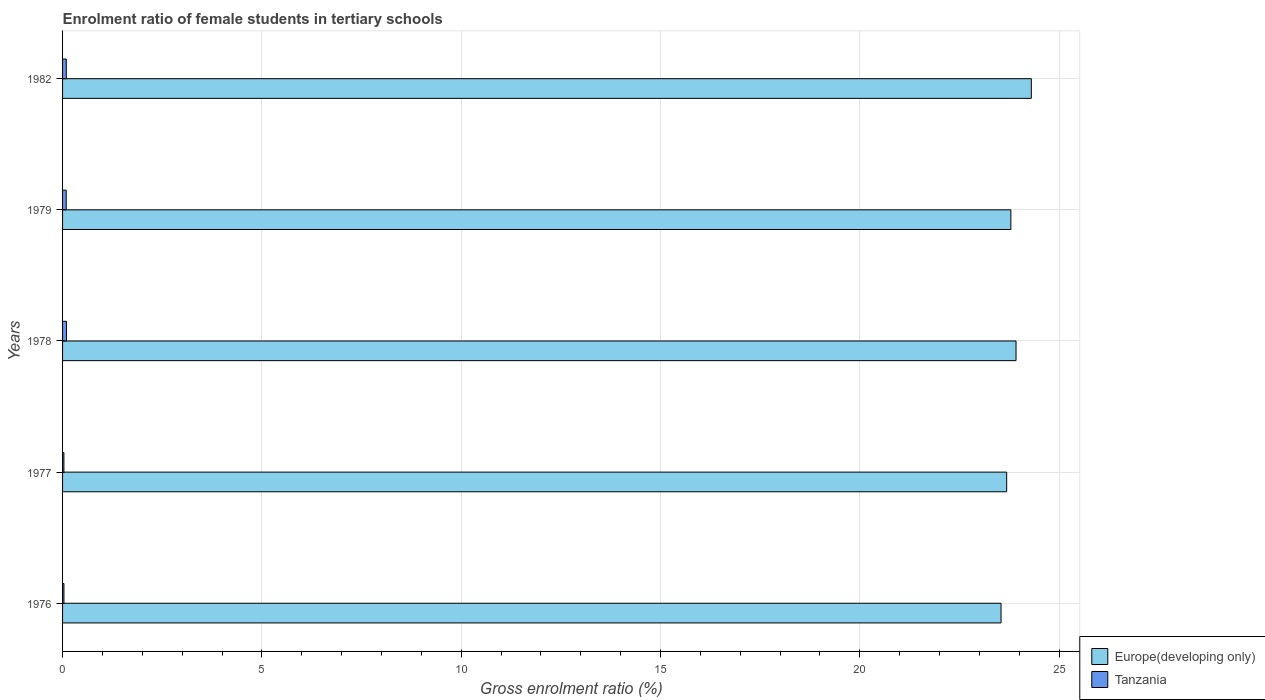How many groups of bars are there?
Give a very brief answer. 5. Are the number of bars on each tick of the Y-axis equal?
Your answer should be very brief. Yes. How many bars are there on the 2nd tick from the top?
Offer a terse response. 2. What is the label of the 2nd group of bars from the top?
Offer a terse response. 1979. What is the enrolment ratio of female students in tertiary schools in Europe(developing only) in 1976?
Your answer should be compact. 23.54. Across all years, what is the maximum enrolment ratio of female students in tertiary schools in Europe(developing only)?
Offer a very short reply. 24.3. Across all years, what is the minimum enrolment ratio of female students in tertiary schools in Europe(developing only)?
Make the answer very short. 23.54. In which year was the enrolment ratio of female students in tertiary schools in Tanzania maximum?
Your answer should be compact. 1978. What is the total enrolment ratio of female students in tertiary schools in Tanzania in the graph?
Your response must be concise. 0.35. What is the difference between the enrolment ratio of female students in tertiary schools in Europe(developing only) in 1979 and that in 1982?
Offer a very short reply. -0.51. What is the difference between the enrolment ratio of female students in tertiary schools in Tanzania in 1977 and the enrolment ratio of female students in tertiary schools in Europe(developing only) in 1976?
Offer a very short reply. -23.51. What is the average enrolment ratio of female students in tertiary schools in Tanzania per year?
Your answer should be compact. 0.07. In the year 1977, what is the difference between the enrolment ratio of female students in tertiary schools in Europe(developing only) and enrolment ratio of female students in tertiary schools in Tanzania?
Ensure brevity in your answer.  23.65. What is the ratio of the enrolment ratio of female students in tertiary schools in Tanzania in 1979 to that in 1982?
Your answer should be compact. 0.97. Is the enrolment ratio of female students in tertiary schools in Tanzania in 1977 less than that in 1979?
Your response must be concise. Yes. Is the difference between the enrolment ratio of female students in tertiary schools in Europe(developing only) in 1976 and 1982 greater than the difference between the enrolment ratio of female students in tertiary schools in Tanzania in 1976 and 1982?
Provide a succinct answer. No. What is the difference between the highest and the second highest enrolment ratio of female students in tertiary schools in Europe(developing only)?
Your answer should be very brief. 0.38. What is the difference between the highest and the lowest enrolment ratio of female students in tertiary schools in Tanzania?
Your response must be concise. 0.06. In how many years, is the enrolment ratio of female students in tertiary schools in Tanzania greater than the average enrolment ratio of female students in tertiary schools in Tanzania taken over all years?
Keep it short and to the point. 3. Is the sum of the enrolment ratio of female students in tertiary schools in Tanzania in 1977 and 1982 greater than the maximum enrolment ratio of female students in tertiary schools in Europe(developing only) across all years?
Your answer should be compact. No. What does the 2nd bar from the top in 1979 represents?
Ensure brevity in your answer.  Europe(developing only). What does the 2nd bar from the bottom in 1977 represents?
Provide a short and direct response. Tanzania. How many years are there in the graph?
Keep it short and to the point. 5. Are the values on the major ticks of X-axis written in scientific E-notation?
Offer a terse response. No. Does the graph contain any zero values?
Make the answer very short. No. What is the title of the graph?
Your answer should be very brief. Enrolment ratio of female students in tertiary schools. Does "Malaysia" appear as one of the legend labels in the graph?
Give a very brief answer. No. What is the Gross enrolment ratio (%) of Europe(developing only) in 1976?
Your response must be concise. 23.54. What is the Gross enrolment ratio (%) in Tanzania in 1976?
Make the answer very short. 0.03. What is the Gross enrolment ratio (%) in Europe(developing only) in 1977?
Give a very brief answer. 23.68. What is the Gross enrolment ratio (%) of Tanzania in 1977?
Make the answer very short. 0.03. What is the Gross enrolment ratio (%) in Europe(developing only) in 1978?
Make the answer very short. 23.92. What is the Gross enrolment ratio (%) in Tanzania in 1978?
Give a very brief answer. 0.1. What is the Gross enrolment ratio (%) of Europe(developing only) in 1979?
Make the answer very short. 23.79. What is the Gross enrolment ratio (%) in Tanzania in 1979?
Your answer should be very brief. 0.09. What is the Gross enrolment ratio (%) in Europe(developing only) in 1982?
Make the answer very short. 24.3. What is the Gross enrolment ratio (%) of Tanzania in 1982?
Your answer should be very brief. 0.09. Across all years, what is the maximum Gross enrolment ratio (%) in Europe(developing only)?
Make the answer very short. 24.3. Across all years, what is the maximum Gross enrolment ratio (%) in Tanzania?
Provide a short and direct response. 0.1. Across all years, what is the minimum Gross enrolment ratio (%) in Europe(developing only)?
Make the answer very short. 23.54. Across all years, what is the minimum Gross enrolment ratio (%) in Tanzania?
Provide a succinct answer. 0.03. What is the total Gross enrolment ratio (%) of Europe(developing only) in the graph?
Give a very brief answer. 119.23. What is the total Gross enrolment ratio (%) of Tanzania in the graph?
Ensure brevity in your answer.  0.35. What is the difference between the Gross enrolment ratio (%) in Europe(developing only) in 1976 and that in 1977?
Provide a succinct answer. -0.14. What is the difference between the Gross enrolment ratio (%) in Tanzania in 1976 and that in 1977?
Your answer should be compact. 0. What is the difference between the Gross enrolment ratio (%) in Europe(developing only) in 1976 and that in 1978?
Your response must be concise. -0.38. What is the difference between the Gross enrolment ratio (%) of Tanzania in 1976 and that in 1978?
Give a very brief answer. -0.06. What is the difference between the Gross enrolment ratio (%) in Europe(developing only) in 1976 and that in 1979?
Your response must be concise. -0.25. What is the difference between the Gross enrolment ratio (%) of Tanzania in 1976 and that in 1979?
Give a very brief answer. -0.06. What is the difference between the Gross enrolment ratio (%) of Europe(developing only) in 1976 and that in 1982?
Offer a terse response. -0.76. What is the difference between the Gross enrolment ratio (%) of Tanzania in 1976 and that in 1982?
Offer a terse response. -0.06. What is the difference between the Gross enrolment ratio (%) of Europe(developing only) in 1977 and that in 1978?
Ensure brevity in your answer.  -0.23. What is the difference between the Gross enrolment ratio (%) of Tanzania in 1977 and that in 1978?
Ensure brevity in your answer.  -0.06. What is the difference between the Gross enrolment ratio (%) in Europe(developing only) in 1977 and that in 1979?
Your answer should be very brief. -0.11. What is the difference between the Gross enrolment ratio (%) in Tanzania in 1977 and that in 1979?
Offer a very short reply. -0.06. What is the difference between the Gross enrolment ratio (%) of Europe(developing only) in 1977 and that in 1982?
Offer a terse response. -0.62. What is the difference between the Gross enrolment ratio (%) of Tanzania in 1977 and that in 1982?
Keep it short and to the point. -0.06. What is the difference between the Gross enrolment ratio (%) in Europe(developing only) in 1978 and that in 1979?
Provide a succinct answer. 0.13. What is the difference between the Gross enrolment ratio (%) in Tanzania in 1978 and that in 1979?
Ensure brevity in your answer.  0.01. What is the difference between the Gross enrolment ratio (%) of Europe(developing only) in 1978 and that in 1982?
Provide a short and direct response. -0.38. What is the difference between the Gross enrolment ratio (%) in Tanzania in 1978 and that in 1982?
Ensure brevity in your answer.  0. What is the difference between the Gross enrolment ratio (%) in Europe(developing only) in 1979 and that in 1982?
Provide a succinct answer. -0.51. What is the difference between the Gross enrolment ratio (%) of Tanzania in 1979 and that in 1982?
Your answer should be compact. -0. What is the difference between the Gross enrolment ratio (%) in Europe(developing only) in 1976 and the Gross enrolment ratio (%) in Tanzania in 1977?
Your response must be concise. 23.51. What is the difference between the Gross enrolment ratio (%) of Europe(developing only) in 1976 and the Gross enrolment ratio (%) of Tanzania in 1978?
Give a very brief answer. 23.44. What is the difference between the Gross enrolment ratio (%) of Europe(developing only) in 1976 and the Gross enrolment ratio (%) of Tanzania in 1979?
Give a very brief answer. 23.45. What is the difference between the Gross enrolment ratio (%) of Europe(developing only) in 1976 and the Gross enrolment ratio (%) of Tanzania in 1982?
Provide a short and direct response. 23.45. What is the difference between the Gross enrolment ratio (%) of Europe(developing only) in 1977 and the Gross enrolment ratio (%) of Tanzania in 1978?
Keep it short and to the point. 23.59. What is the difference between the Gross enrolment ratio (%) of Europe(developing only) in 1977 and the Gross enrolment ratio (%) of Tanzania in 1979?
Make the answer very short. 23.59. What is the difference between the Gross enrolment ratio (%) of Europe(developing only) in 1977 and the Gross enrolment ratio (%) of Tanzania in 1982?
Provide a short and direct response. 23.59. What is the difference between the Gross enrolment ratio (%) of Europe(developing only) in 1978 and the Gross enrolment ratio (%) of Tanzania in 1979?
Offer a very short reply. 23.83. What is the difference between the Gross enrolment ratio (%) of Europe(developing only) in 1978 and the Gross enrolment ratio (%) of Tanzania in 1982?
Your answer should be compact. 23.82. What is the difference between the Gross enrolment ratio (%) of Europe(developing only) in 1979 and the Gross enrolment ratio (%) of Tanzania in 1982?
Provide a succinct answer. 23.69. What is the average Gross enrolment ratio (%) of Europe(developing only) per year?
Ensure brevity in your answer.  23.85. What is the average Gross enrolment ratio (%) of Tanzania per year?
Ensure brevity in your answer.  0.07. In the year 1976, what is the difference between the Gross enrolment ratio (%) in Europe(developing only) and Gross enrolment ratio (%) in Tanzania?
Offer a very short reply. 23.51. In the year 1977, what is the difference between the Gross enrolment ratio (%) of Europe(developing only) and Gross enrolment ratio (%) of Tanzania?
Give a very brief answer. 23.65. In the year 1978, what is the difference between the Gross enrolment ratio (%) of Europe(developing only) and Gross enrolment ratio (%) of Tanzania?
Offer a very short reply. 23.82. In the year 1979, what is the difference between the Gross enrolment ratio (%) in Europe(developing only) and Gross enrolment ratio (%) in Tanzania?
Offer a terse response. 23.7. In the year 1982, what is the difference between the Gross enrolment ratio (%) in Europe(developing only) and Gross enrolment ratio (%) in Tanzania?
Keep it short and to the point. 24.21. What is the ratio of the Gross enrolment ratio (%) in Europe(developing only) in 1976 to that in 1977?
Ensure brevity in your answer.  0.99. What is the ratio of the Gross enrolment ratio (%) in Tanzania in 1976 to that in 1977?
Give a very brief answer. 1.02. What is the ratio of the Gross enrolment ratio (%) of Europe(developing only) in 1976 to that in 1978?
Provide a succinct answer. 0.98. What is the ratio of the Gross enrolment ratio (%) in Tanzania in 1976 to that in 1978?
Make the answer very short. 0.35. What is the ratio of the Gross enrolment ratio (%) in Europe(developing only) in 1976 to that in 1979?
Give a very brief answer. 0.99. What is the ratio of the Gross enrolment ratio (%) of Tanzania in 1976 to that in 1979?
Your answer should be compact. 0.38. What is the ratio of the Gross enrolment ratio (%) of Europe(developing only) in 1976 to that in 1982?
Offer a very short reply. 0.97. What is the ratio of the Gross enrolment ratio (%) in Tanzania in 1976 to that in 1982?
Your answer should be very brief. 0.37. What is the ratio of the Gross enrolment ratio (%) in Europe(developing only) in 1977 to that in 1978?
Keep it short and to the point. 0.99. What is the ratio of the Gross enrolment ratio (%) in Tanzania in 1977 to that in 1978?
Give a very brief answer. 0.34. What is the ratio of the Gross enrolment ratio (%) in Europe(developing only) in 1977 to that in 1979?
Your response must be concise. 1. What is the ratio of the Gross enrolment ratio (%) in Tanzania in 1977 to that in 1979?
Offer a terse response. 0.37. What is the ratio of the Gross enrolment ratio (%) of Europe(developing only) in 1977 to that in 1982?
Make the answer very short. 0.97. What is the ratio of the Gross enrolment ratio (%) of Tanzania in 1977 to that in 1982?
Give a very brief answer. 0.36. What is the ratio of the Gross enrolment ratio (%) in Europe(developing only) in 1978 to that in 1979?
Give a very brief answer. 1.01. What is the ratio of the Gross enrolment ratio (%) of Tanzania in 1978 to that in 1979?
Provide a short and direct response. 1.08. What is the ratio of the Gross enrolment ratio (%) of Europe(developing only) in 1978 to that in 1982?
Your answer should be very brief. 0.98. What is the ratio of the Gross enrolment ratio (%) of Tanzania in 1978 to that in 1982?
Keep it short and to the point. 1.05. What is the ratio of the Gross enrolment ratio (%) in Europe(developing only) in 1979 to that in 1982?
Your response must be concise. 0.98. What is the ratio of the Gross enrolment ratio (%) in Tanzania in 1979 to that in 1982?
Make the answer very short. 0.97. What is the difference between the highest and the second highest Gross enrolment ratio (%) of Europe(developing only)?
Make the answer very short. 0.38. What is the difference between the highest and the second highest Gross enrolment ratio (%) in Tanzania?
Offer a very short reply. 0. What is the difference between the highest and the lowest Gross enrolment ratio (%) of Europe(developing only)?
Your answer should be compact. 0.76. What is the difference between the highest and the lowest Gross enrolment ratio (%) of Tanzania?
Keep it short and to the point. 0.06. 